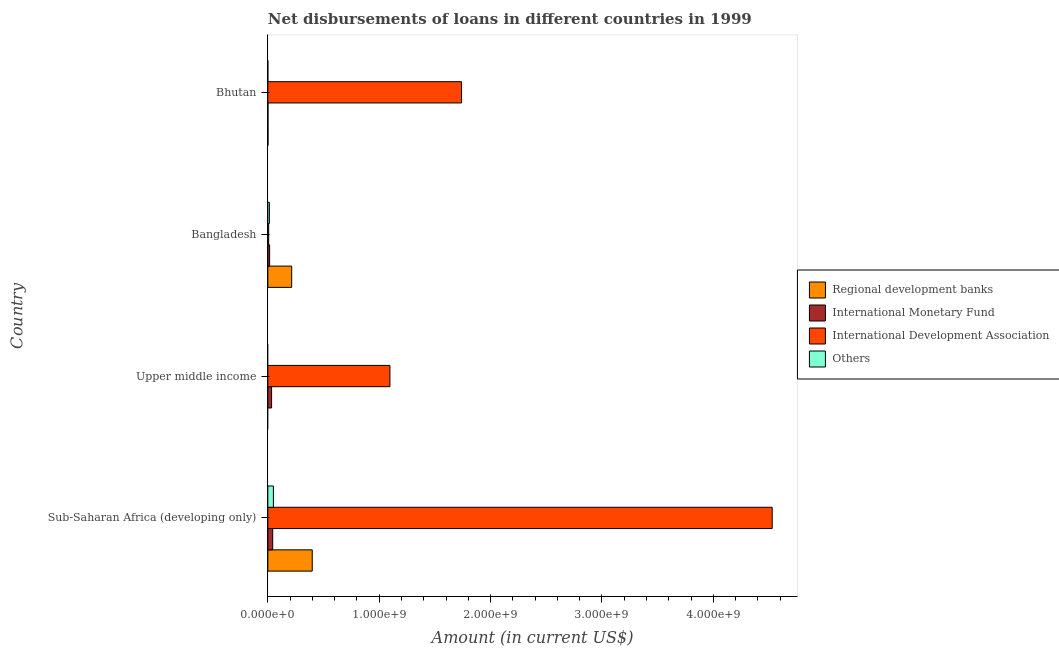How many different coloured bars are there?
Keep it short and to the point. 4. How many groups of bars are there?
Offer a very short reply. 4. Are the number of bars per tick equal to the number of legend labels?
Provide a succinct answer. No. How many bars are there on the 3rd tick from the top?
Keep it short and to the point. 2. What is the label of the 1st group of bars from the top?
Your answer should be compact. Bhutan. In how many cases, is the number of bars for a given country not equal to the number of legend labels?
Your response must be concise. 2. What is the amount of loan disimbursed by other organisations in Upper middle income?
Your response must be concise. 0. Across all countries, what is the maximum amount of loan disimbursed by international monetary fund?
Offer a terse response. 4.36e+07. Across all countries, what is the minimum amount of loan disimbursed by international development association?
Offer a very short reply. 7.42e+06. In which country was the amount of loan disimbursed by regional development banks maximum?
Offer a very short reply. Sub-Saharan Africa (developing only). What is the total amount of loan disimbursed by international development association in the graph?
Give a very brief answer. 7.37e+09. What is the difference between the amount of loan disimbursed by international development association in Bhutan and that in Sub-Saharan Africa (developing only)?
Give a very brief answer. -2.79e+09. What is the difference between the amount of loan disimbursed by international development association in Sub-Saharan Africa (developing only) and the amount of loan disimbursed by international monetary fund in Upper middle income?
Offer a very short reply. 4.50e+09. What is the average amount of loan disimbursed by international development association per country?
Provide a short and direct response. 1.84e+09. What is the difference between the amount of loan disimbursed by regional development banks and amount of loan disimbursed by international development association in Sub-Saharan Africa (developing only)?
Offer a terse response. -4.13e+09. What is the ratio of the amount of loan disimbursed by international monetary fund in Bangladesh to that in Sub-Saharan Africa (developing only)?
Your answer should be very brief. 0.37. Is the amount of loan disimbursed by regional development banks in Bangladesh less than that in Sub-Saharan Africa (developing only)?
Offer a terse response. Yes. Is the difference between the amount of loan disimbursed by regional development banks in Bangladesh and Bhutan greater than the difference between the amount of loan disimbursed by international development association in Bangladesh and Bhutan?
Keep it short and to the point. Yes. What is the difference between the highest and the second highest amount of loan disimbursed by regional development banks?
Your response must be concise. 1.85e+08. What is the difference between the highest and the lowest amount of loan disimbursed by other organisations?
Your response must be concise. 4.98e+07. In how many countries, is the amount of loan disimbursed by international monetary fund greater than the average amount of loan disimbursed by international monetary fund taken over all countries?
Offer a terse response. 2. Is the sum of the amount of loan disimbursed by other organisations in Bangladesh and Sub-Saharan Africa (developing only) greater than the maximum amount of loan disimbursed by regional development banks across all countries?
Give a very brief answer. No. Is it the case that in every country, the sum of the amount of loan disimbursed by international development association and amount of loan disimbursed by international monetary fund is greater than the sum of amount of loan disimbursed by regional development banks and amount of loan disimbursed by other organisations?
Your answer should be very brief. No. Is it the case that in every country, the sum of the amount of loan disimbursed by regional development banks and amount of loan disimbursed by international monetary fund is greater than the amount of loan disimbursed by international development association?
Make the answer very short. No. How many countries are there in the graph?
Provide a succinct answer. 4. What is the difference between two consecutive major ticks on the X-axis?
Offer a terse response. 1.00e+09. Are the values on the major ticks of X-axis written in scientific E-notation?
Provide a succinct answer. Yes. Does the graph contain grids?
Provide a short and direct response. No. What is the title of the graph?
Offer a very short reply. Net disbursements of loans in different countries in 1999. Does "Negligence towards children" appear as one of the legend labels in the graph?
Provide a succinct answer. No. What is the label or title of the X-axis?
Give a very brief answer. Amount (in current US$). What is the Amount (in current US$) in Regional development banks in Sub-Saharan Africa (developing only)?
Your answer should be compact. 3.99e+08. What is the Amount (in current US$) in International Monetary Fund in Sub-Saharan Africa (developing only)?
Offer a terse response. 4.36e+07. What is the Amount (in current US$) of International Development Association in Sub-Saharan Africa (developing only)?
Offer a very short reply. 4.53e+09. What is the Amount (in current US$) of Others in Sub-Saharan Africa (developing only)?
Provide a short and direct response. 4.98e+07. What is the Amount (in current US$) in International Monetary Fund in Upper middle income?
Ensure brevity in your answer.  3.36e+07. What is the Amount (in current US$) in International Development Association in Upper middle income?
Offer a very short reply. 1.10e+09. What is the Amount (in current US$) in Regional development banks in Bangladesh?
Your answer should be very brief. 2.14e+08. What is the Amount (in current US$) of International Monetary Fund in Bangladesh?
Provide a succinct answer. 1.60e+07. What is the Amount (in current US$) of International Development Association in Bangladesh?
Provide a short and direct response. 7.42e+06. What is the Amount (in current US$) in Others in Bangladesh?
Offer a very short reply. 1.37e+07. What is the Amount (in current US$) of Regional development banks in Bhutan?
Your answer should be compact. 1.33e+06. What is the Amount (in current US$) of International Monetary Fund in Bhutan?
Offer a terse response. 9.68e+05. What is the Amount (in current US$) of International Development Association in Bhutan?
Make the answer very short. 1.74e+09. What is the Amount (in current US$) of Others in Bhutan?
Keep it short and to the point. 0. Across all countries, what is the maximum Amount (in current US$) in Regional development banks?
Offer a very short reply. 3.99e+08. Across all countries, what is the maximum Amount (in current US$) of International Monetary Fund?
Offer a terse response. 4.36e+07. Across all countries, what is the maximum Amount (in current US$) in International Development Association?
Provide a succinct answer. 4.53e+09. Across all countries, what is the maximum Amount (in current US$) in Others?
Keep it short and to the point. 4.98e+07. Across all countries, what is the minimum Amount (in current US$) of International Monetary Fund?
Provide a short and direct response. 9.68e+05. Across all countries, what is the minimum Amount (in current US$) of International Development Association?
Keep it short and to the point. 7.42e+06. Across all countries, what is the minimum Amount (in current US$) in Others?
Offer a very short reply. 0. What is the total Amount (in current US$) in Regional development banks in the graph?
Provide a succinct answer. 6.14e+08. What is the total Amount (in current US$) of International Monetary Fund in the graph?
Your answer should be very brief. 9.42e+07. What is the total Amount (in current US$) of International Development Association in the graph?
Your answer should be very brief. 7.37e+09. What is the total Amount (in current US$) in Others in the graph?
Make the answer very short. 6.35e+07. What is the difference between the Amount (in current US$) of International Monetary Fund in Sub-Saharan Africa (developing only) and that in Upper middle income?
Keep it short and to the point. 9.95e+06. What is the difference between the Amount (in current US$) of International Development Association in Sub-Saharan Africa (developing only) and that in Upper middle income?
Give a very brief answer. 3.43e+09. What is the difference between the Amount (in current US$) in Regional development banks in Sub-Saharan Africa (developing only) and that in Bangladesh?
Make the answer very short. 1.85e+08. What is the difference between the Amount (in current US$) in International Monetary Fund in Sub-Saharan Africa (developing only) and that in Bangladesh?
Ensure brevity in your answer.  2.76e+07. What is the difference between the Amount (in current US$) in International Development Association in Sub-Saharan Africa (developing only) and that in Bangladesh?
Provide a short and direct response. 4.52e+09. What is the difference between the Amount (in current US$) in Others in Sub-Saharan Africa (developing only) and that in Bangladesh?
Provide a succinct answer. 3.60e+07. What is the difference between the Amount (in current US$) of Regional development banks in Sub-Saharan Africa (developing only) and that in Bhutan?
Provide a succinct answer. 3.97e+08. What is the difference between the Amount (in current US$) in International Monetary Fund in Sub-Saharan Africa (developing only) and that in Bhutan?
Ensure brevity in your answer.  4.26e+07. What is the difference between the Amount (in current US$) of International Development Association in Sub-Saharan Africa (developing only) and that in Bhutan?
Offer a terse response. 2.79e+09. What is the difference between the Amount (in current US$) in International Monetary Fund in Upper middle income and that in Bangladesh?
Make the answer very short. 1.76e+07. What is the difference between the Amount (in current US$) in International Development Association in Upper middle income and that in Bangladesh?
Ensure brevity in your answer.  1.09e+09. What is the difference between the Amount (in current US$) of International Monetary Fund in Upper middle income and that in Bhutan?
Offer a terse response. 3.27e+07. What is the difference between the Amount (in current US$) of International Development Association in Upper middle income and that in Bhutan?
Make the answer very short. -6.43e+08. What is the difference between the Amount (in current US$) in Regional development banks in Bangladesh and that in Bhutan?
Provide a succinct answer. 2.13e+08. What is the difference between the Amount (in current US$) in International Monetary Fund in Bangladesh and that in Bhutan?
Keep it short and to the point. 1.50e+07. What is the difference between the Amount (in current US$) of International Development Association in Bangladesh and that in Bhutan?
Your response must be concise. -1.73e+09. What is the difference between the Amount (in current US$) in Regional development banks in Sub-Saharan Africa (developing only) and the Amount (in current US$) in International Monetary Fund in Upper middle income?
Your response must be concise. 3.65e+08. What is the difference between the Amount (in current US$) in Regional development banks in Sub-Saharan Africa (developing only) and the Amount (in current US$) in International Development Association in Upper middle income?
Your answer should be very brief. -6.97e+08. What is the difference between the Amount (in current US$) of International Monetary Fund in Sub-Saharan Africa (developing only) and the Amount (in current US$) of International Development Association in Upper middle income?
Provide a succinct answer. -1.05e+09. What is the difference between the Amount (in current US$) of Regional development banks in Sub-Saharan Africa (developing only) and the Amount (in current US$) of International Monetary Fund in Bangladesh?
Your answer should be compact. 3.83e+08. What is the difference between the Amount (in current US$) of Regional development banks in Sub-Saharan Africa (developing only) and the Amount (in current US$) of International Development Association in Bangladesh?
Your response must be concise. 3.91e+08. What is the difference between the Amount (in current US$) of Regional development banks in Sub-Saharan Africa (developing only) and the Amount (in current US$) of Others in Bangladesh?
Give a very brief answer. 3.85e+08. What is the difference between the Amount (in current US$) in International Monetary Fund in Sub-Saharan Africa (developing only) and the Amount (in current US$) in International Development Association in Bangladesh?
Offer a very short reply. 3.62e+07. What is the difference between the Amount (in current US$) of International Monetary Fund in Sub-Saharan Africa (developing only) and the Amount (in current US$) of Others in Bangladesh?
Keep it short and to the point. 2.98e+07. What is the difference between the Amount (in current US$) in International Development Association in Sub-Saharan Africa (developing only) and the Amount (in current US$) in Others in Bangladesh?
Ensure brevity in your answer.  4.51e+09. What is the difference between the Amount (in current US$) of Regional development banks in Sub-Saharan Africa (developing only) and the Amount (in current US$) of International Monetary Fund in Bhutan?
Give a very brief answer. 3.98e+08. What is the difference between the Amount (in current US$) of Regional development banks in Sub-Saharan Africa (developing only) and the Amount (in current US$) of International Development Association in Bhutan?
Ensure brevity in your answer.  -1.34e+09. What is the difference between the Amount (in current US$) of International Monetary Fund in Sub-Saharan Africa (developing only) and the Amount (in current US$) of International Development Association in Bhutan?
Provide a succinct answer. -1.70e+09. What is the difference between the Amount (in current US$) of International Monetary Fund in Upper middle income and the Amount (in current US$) of International Development Association in Bangladesh?
Your answer should be compact. 2.62e+07. What is the difference between the Amount (in current US$) of International Monetary Fund in Upper middle income and the Amount (in current US$) of Others in Bangladesh?
Offer a terse response. 1.99e+07. What is the difference between the Amount (in current US$) of International Development Association in Upper middle income and the Amount (in current US$) of Others in Bangladesh?
Ensure brevity in your answer.  1.08e+09. What is the difference between the Amount (in current US$) in International Monetary Fund in Upper middle income and the Amount (in current US$) in International Development Association in Bhutan?
Offer a terse response. -1.71e+09. What is the difference between the Amount (in current US$) in Regional development banks in Bangladesh and the Amount (in current US$) in International Monetary Fund in Bhutan?
Make the answer very short. 2.13e+08. What is the difference between the Amount (in current US$) in Regional development banks in Bangladesh and the Amount (in current US$) in International Development Association in Bhutan?
Provide a succinct answer. -1.53e+09. What is the difference between the Amount (in current US$) in International Monetary Fund in Bangladesh and the Amount (in current US$) in International Development Association in Bhutan?
Your response must be concise. -1.72e+09. What is the average Amount (in current US$) in Regional development banks per country?
Your answer should be very brief. 1.54e+08. What is the average Amount (in current US$) in International Monetary Fund per country?
Your answer should be compact. 2.35e+07. What is the average Amount (in current US$) in International Development Association per country?
Offer a very short reply. 1.84e+09. What is the average Amount (in current US$) of Others per country?
Your answer should be very brief. 1.59e+07. What is the difference between the Amount (in current US$) of Regional development banks and Amount (in current US$) of International Monetary Fund in Sub-Saharan Africa (developing only)?
Provide a short and direct response. 3.55e+08. What is the difference between the Amount (in current US$) of Regional development banks and Amount (in current US$) of International Development Association in Sub-Saharan Africa (developing only)?
Give a very brief answer. -4.13e+09. What is the difference between the Amount (in current US$) of Regional development banks and Amount (in current US$) of Others in Sub-Saharan Africa (developing only)?
Provide a short and direct response. 3.49e+08. What is the difference between the Amount (in current US$) of International Monetary Fund and Amount (in current US$) of International Development Association in Sub-Saharan Africa (developing only)?
Provide a succinct answer. -4.49e+09. What is the difference between the Amount (in current US$) in International Monetary Fund and Amount (in current US$) in Others in Sub-Saharan Africa (developing only)?
Provide a succinct answer. -6.21e+06. What is the difference between the Amount (in current US$) in International Development Association and Amount (in current US$) in Others in Sub-Saharan Africa (developing only)?
Your answer should be very brief. 4.48e+09. What is the difference between the Amount (in current US$) of International Monetary Fund and Amount (in current US$) of International Development Association in Upper middle income?
Your answer should be very brief. -1.06e+09. What is the difference between the Amount (in current US$) of Regional development banks and Amount (in current US$) of International Monetary Fund in Bangladesh?
Ensure brevity in your answer.  1.98e+08. What is the difference between the Amount (in current US$) in Regional development banks and Amount (in current US$) in International Development Association in Bangladesh?
Ensure brevity in your answer.  2.07e+08. What is the difference between the Amount (in current US$) in Regional development banks and Amount (in current US$) in Others in Bangladesh?
Your answer should be very brief. 2.00e+08. What is the difference between the Amount (in current US$) in International Monetary Fund and Amount (in current US$) in International Development Association in Bangladesh?
Ensure brevity in your answer.  8.57e+06. What is the difference between the Amount (in current US$) of International Monetary Fund and Amount (in current US$) of Others in Bangladesh?
Your answer should be very brief. 2.26e+06. What is the difference between the Amount (in current US$) in International Development Association and Amount (in current US$) in Others in Bangladesh?
Provide a succinct answer. -6.31e+06. What is the difference between the Amount (in current US$) of Regional development banks and Amount (in current US$) of International Monetary Fund in Bhutan?
Your answer should be compact. 3.65e+05. What is the difference between the Amount (in current US$) of Regional development banks and Amount (in current US$) of International Development Association in Bhutan?
Your response must be concise. -1.74e+09. What is the difference between the Amount (in current US$) in International Monetary Fund and Amount (in current US$) in International Development Association in Bhutan?
Your answer should be very brief. -1.74e+09. What is the ratio of the Amount (in current US$) in International Monetary Fund in Sub-Saharan Africa (developing only) to that in Upper middle income?
Make the answer very short. 1.3. What is the ratio of the Amount (in current US$) in International Development Association in Sub-Saharan Africa (developing only) to that in Upper middle income?
Your response must be concise. 4.13. What is the ratio of the Amount (in current US$) of Regional development banks in Sub-Saharan Africa (developing only) to that in Bangladesh?
Give a very brief answer. 1.86. What is the ratio of the Amount (in current US$) of International Monetary Fund in Sub-Saharan Africa (developing only) to that in Bangladesh?
Offer a terse response. 2.72. What is the ratio of the Amount (in current US$) of International Development Association in Sub-Saharan Africa (developing only) to that in Bangladesh?
Your answer should be very brief. 610. What is the ratio of the Amount (in current US$) in Others in Sub-Saharan Africa (developing only) to that in Bangladesh?
Offer a terse response. 3.62. What is the ratio of the Amount (in current US$) in Regional development banks in Sub-Saharan Africa (developing only) to that in Bhutan?
Give a very brief answer. 299.08. What is the ratio of the Amount (in current US$) in International Monetary Fund in Sub-Saharan Africa (developing only) to that in Bhutan?
Provide a succinct answer. 45.02. What is the ratio of the Amount (in current US$) of International Development Association in Sub-Saharan Africa (developing only) to that in Bhutan?
Ensure brevity in your answer.  2.6. What is the ratio of the Amount (in current US$) of International Monetary Fund in Upper middle income to that in Bangladesh?
Provide a succinct answer. 2.1. What is the ratio of the Amount (in current US$) in International Development Association in Upper middle income to that in Bangladesh?
Ensure brevity in your answer.  147.64. What is the ratio of the Amount (in current US$) in International Monetary Fund in Upper middle income to that in Bhutan?
Offer a very short reply. 34.74. What is the ratio of the Amount (in current US$) of International Development Association in Upper middle income to that in Bhutan?
Ensure brevity in your answer.  0.63. What is the ratio of the Amount (in current US$) of Regional development banks in Bangladesh to that in Bhutan?
Make the answer very short. 160.63. What is the ratio of the Amount (in current US$) of International Monetary Fund in Bangladesh to that in Bhutan?
Provide a succinct answer. 16.53. What is the ratio of the Amount (in current US$) of International Development Association in Bangladesh to that in Bhutan?
Provide a succinct answer. 0. What is the difference between the highest and the second highest Amount (in current US$) of Regional development banks?
Your answer should be very brief. 1.85e+08. What is the difference between the highest and the second highest Amount (in current US$) of International Monetary Fund?
Ensure brevity in your answer.  9.95e+06. What is the difference between the highest and the second highest Amount (in current US$) of International Development Association?
Keep it short and to the point. 2.79e+09. What is the difference between the highest and the lowest Amount (in current US$) in Regional development banks?
Offer a terse response. 3.99e+08. What is the difference between the highest and the lowest Amount (in current US$) in International Monetary Fund?
Provide a succinct answer. 4.26e+07. What is the difference between the highest and the lowest Amount (in current US$) in International Development Association?
Provide a succinct answer. 4.52e+09. What is the difference between the highest and the lowest Amount (in current US$) of Others?
Your response must be concise. 4.98e+07. 